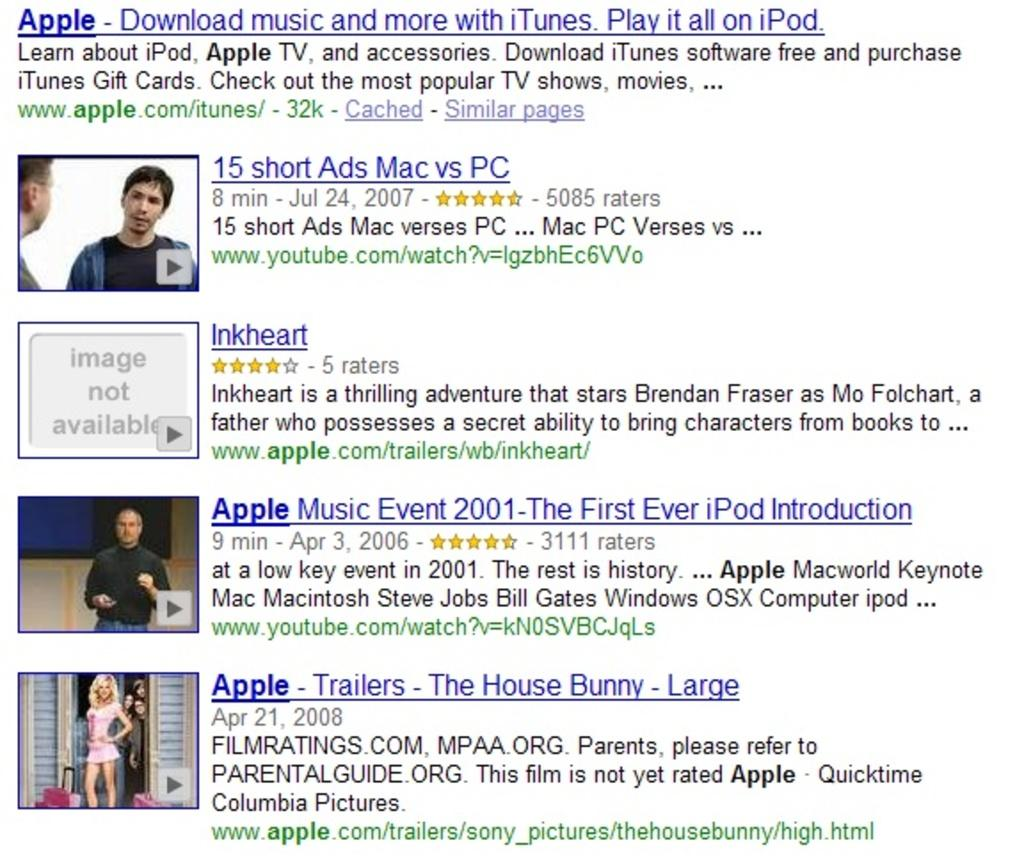What type of content is included in the image? The image contains website links and video clips. What additional information is provided alongside the website links? There is text written under the website links. How many layers of cake can be seen in the image? There is no cake present in the image; it contains website links and video clips. 